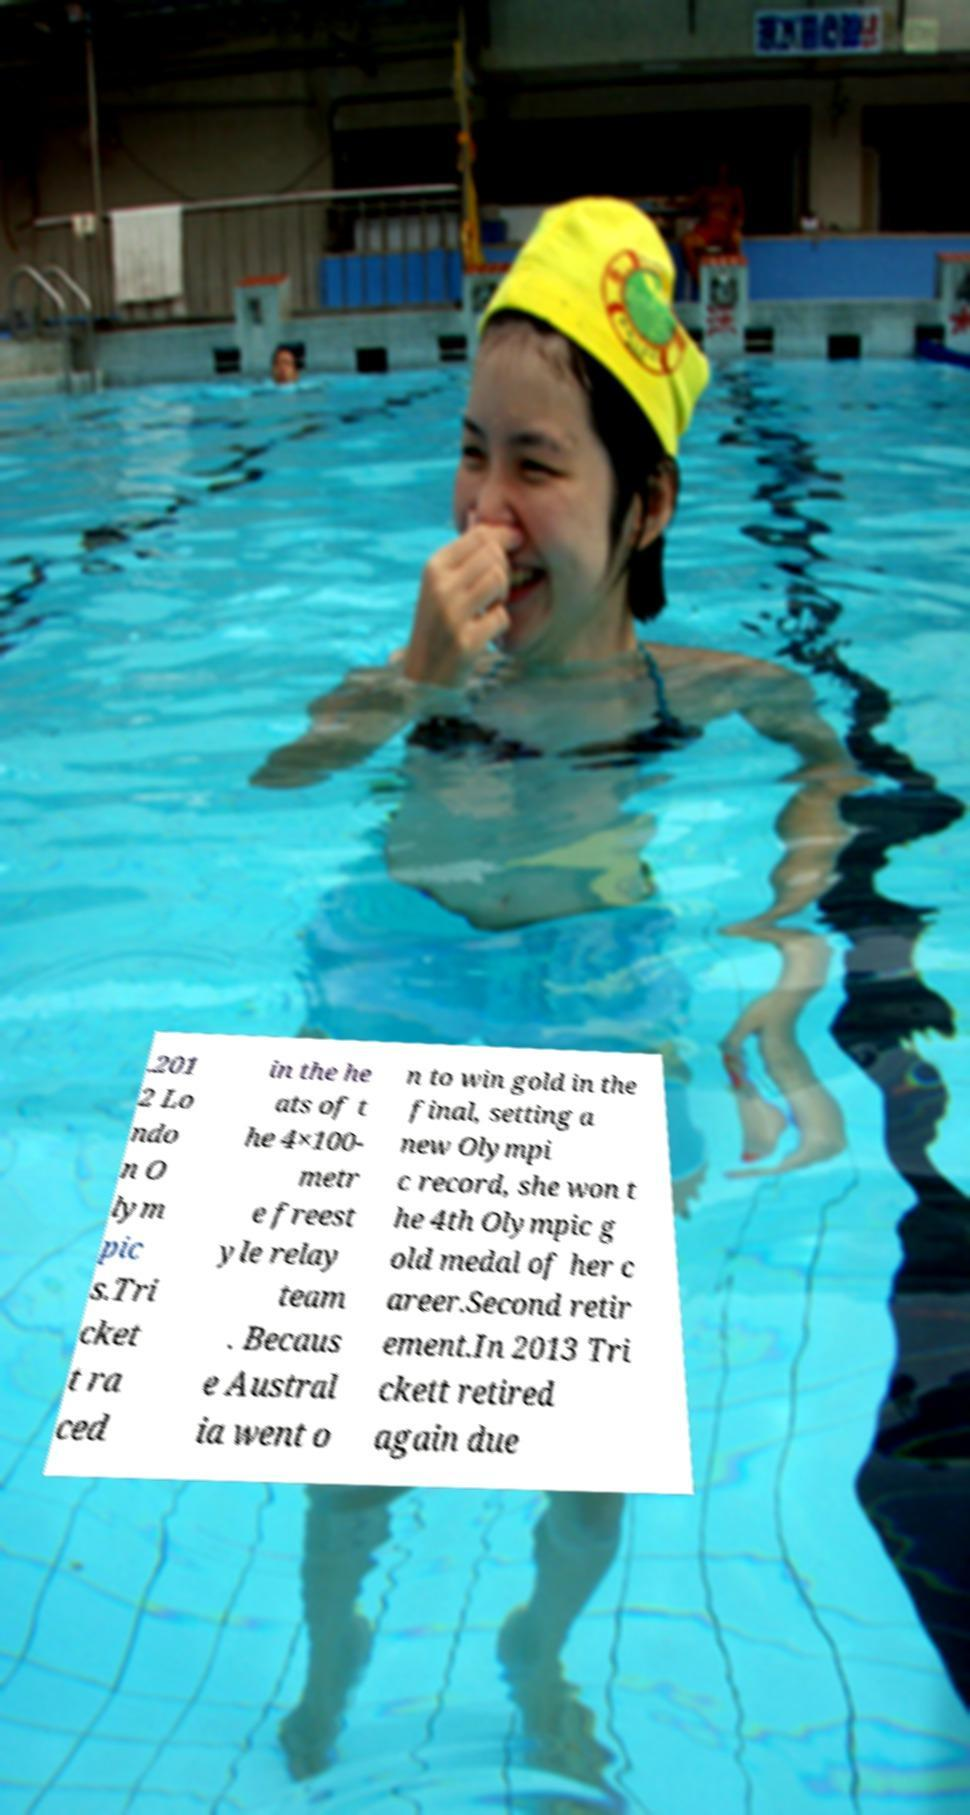Can you accurately transcribe the text from the provided image for me? .201 2 Lo ndo n O lym pic s.Tri cket t ra ced in the he ats of t he 4×100- metr e freest yle relay team . Becaus e Austral ia went o n to win gold in the final, setting a new Olympi c record, she won t he 4th Olympic g old medal of her c areer.Second retir ement.In 2013 Tri ckett retired again due 